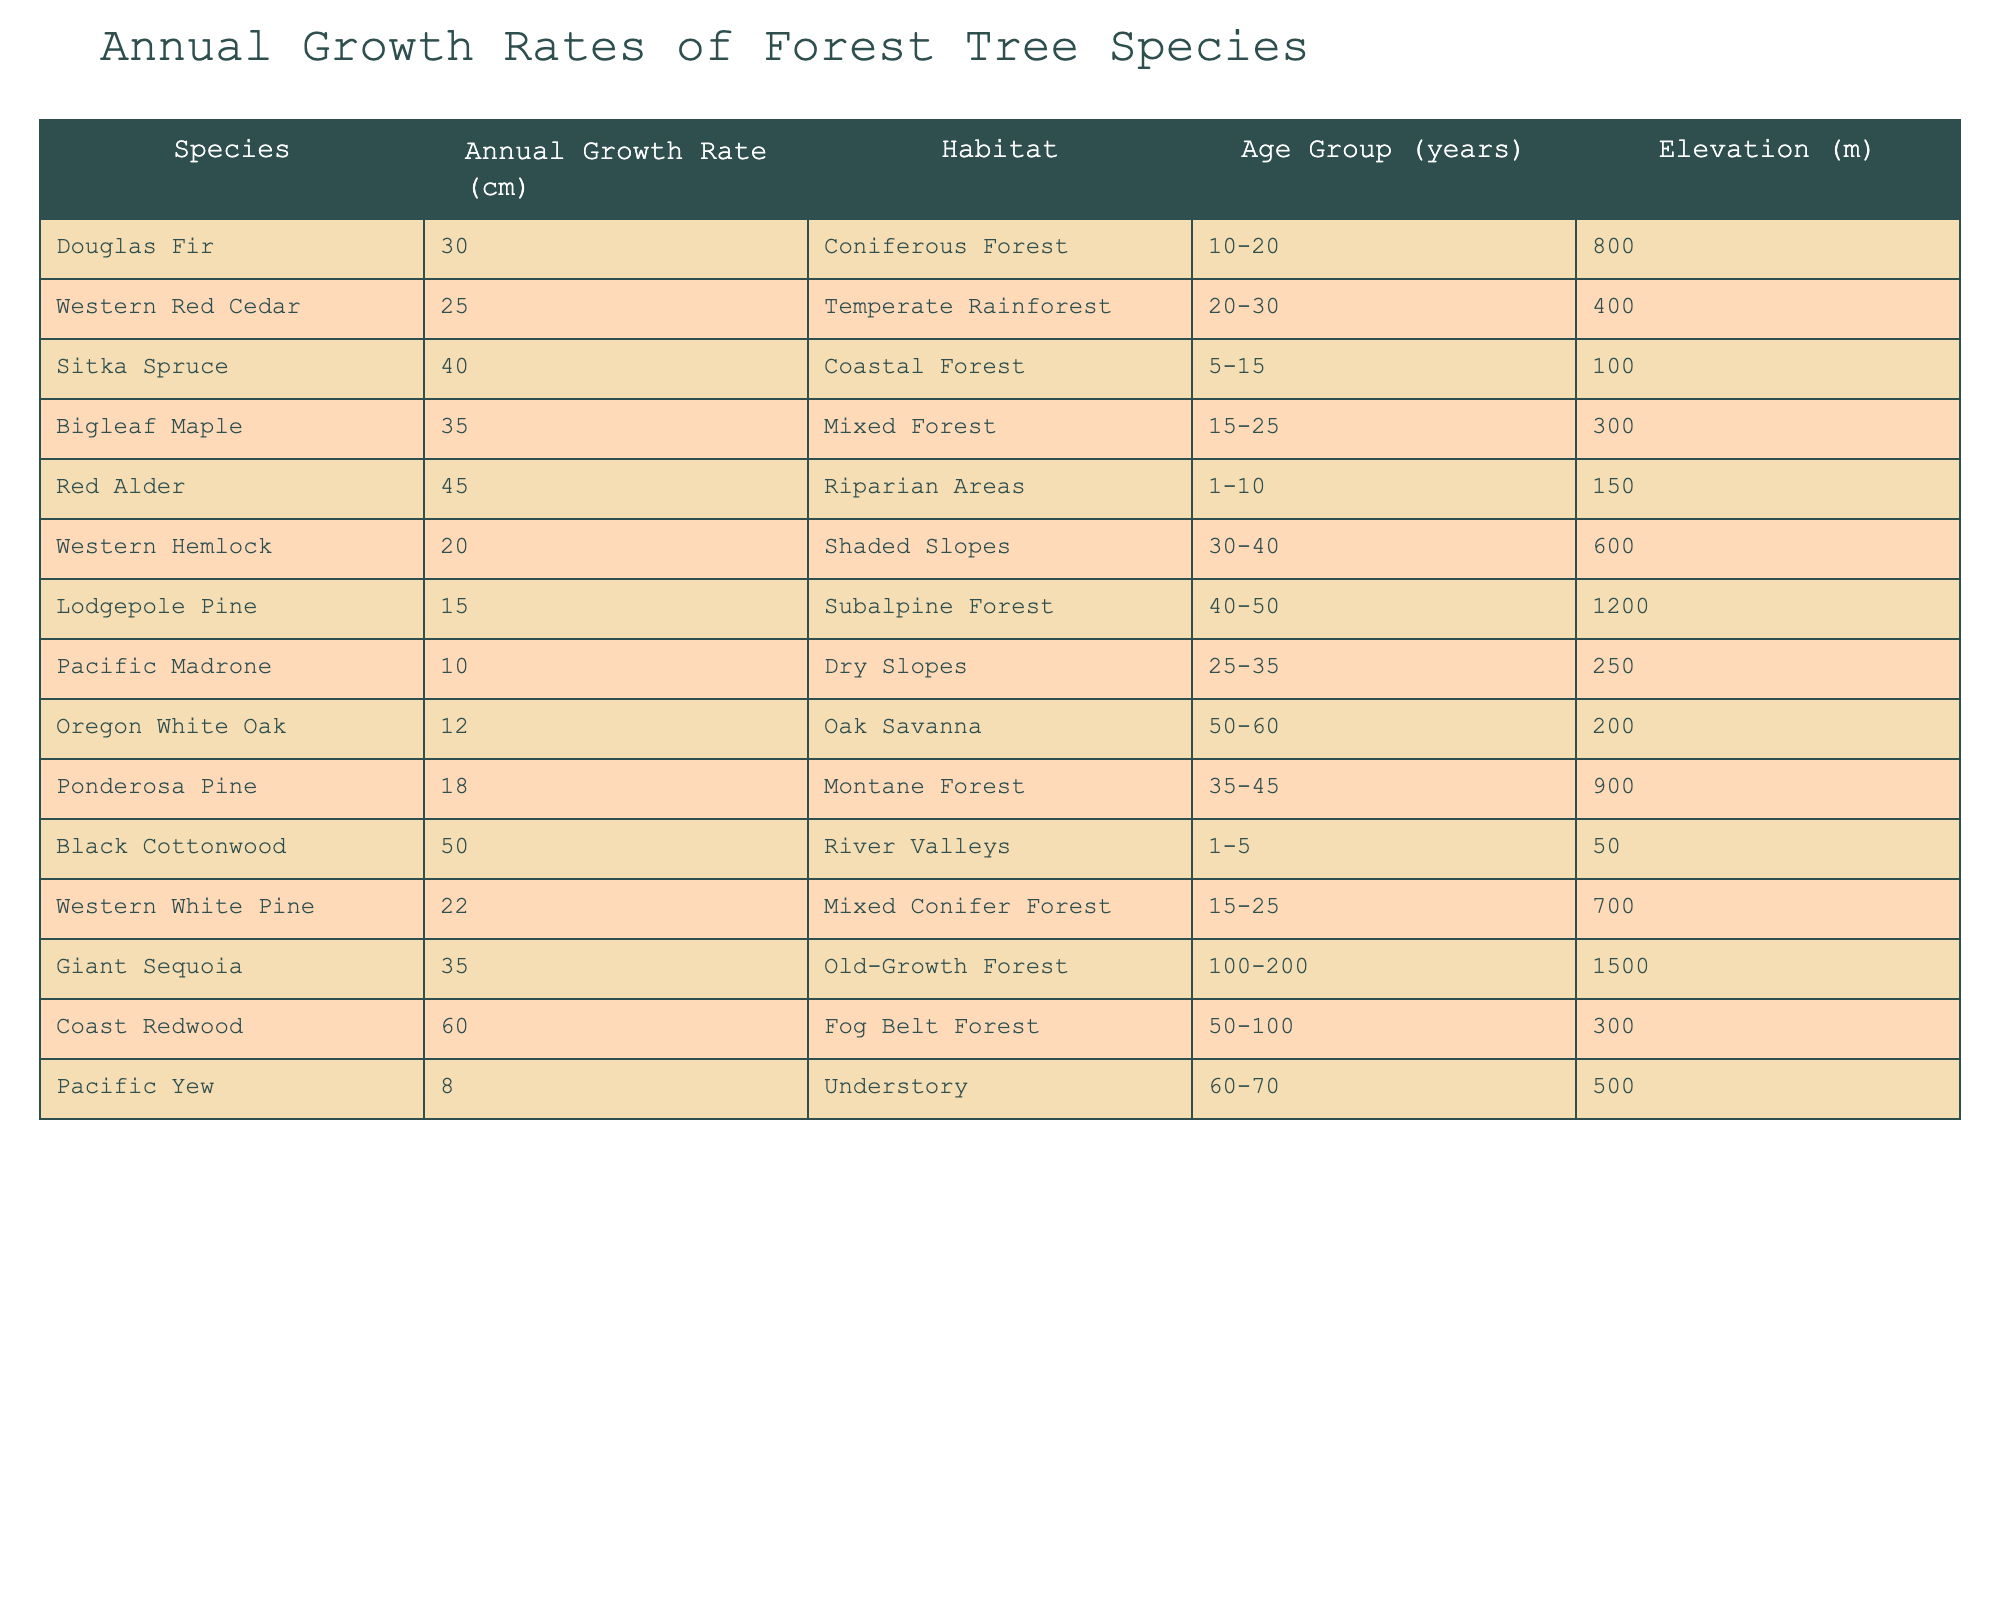What is the annual growth rate of the Coast Redwood? From the table, look for the row corresponding to the Coast Redwood species; the annual growth rate listed there is 60 cm.
Answer: 60 cm Which tree species has the highest annual growth rate? Scanning through the table, I can see that the Black Cottonwood has the highest growth rate at 50 cm, which is more than any other species.
Answer: Black Cottonwood What is the average growth rate of tree species found in Riparian Areas? The only species listed in Riparian Areas is the Red Alder, which has a growth rate of 45 cm. Since there is only one species, the average also equals 45 cm.
Answer: 45 cm Is the Western Hemlock's annual growth rate higher than that of the Lodgepole Pine? The Western Hemlock has an annual growth rate of 20 cm, and the Lodgepole Pine has a growth rate of 15 cm. Since 20 cm is greater than 15 cm, the statement is true.
Answer: Yes How many tree species have an annual growth rate of 30 cm or more? By reviewing the growth rates listed, I see that the following species meet the criterion: Douglas Fir, Sitka Spruce, Bigleaf Maple, Red Alder, Black Cottonwood, and Coast Redwood. That makes a total of 6 species.
Answer: 6 species What is the total annual growth rate of tree species in the Mixed Forest habitat? The table lists two species in Mixed Forest: Bigleaf Maple (35 cm) and Western White Pine (22 cm). Adding these values gives a total of 35 + 22 = 57 cm.
Answer: 57 cm Does the Pacific Yew have a higher growth rate than any species in the Temperate Rainforest? The Pacific Yew has a growth rate of 8 cm. In the Temperate Rainforest, the only species is Western Red Cedar with a growth rate of 25 cm. Since 8 cm is less than 25 cm, the statement is false.
Answer: No What is the difference in growth rates between the maximum and minimum of the species found in the coastal habitats? In the Coastal Forest, the Sitka Spruce has a rate of 40 cm; in the Fog Belt Forest, the Coast Redwood has a rate of 60 cm. To find the difference, calculate 60 - 40 = 20 cm.
Answer: 20 cm Which habitat has the tree species with the second highest annual growth rate? The tree with the highest growth rate is the Coast Redwood in the Fog Belt Forest (60 cm). The second highest is the Black Cottonwood in River Valleys (50 cm). Thus, River Valleys has the second highest species growth rate.
Answer: River Valleys What is the total growth rate of species found in the Understory and Dry Slopes habitats combined? The Pacific Yew (Understory) has a growth rate of 8 cm, while the Pacific Madrone (Dry Slopes) has a growth rate of 10 cm. Adding these gives 8 + 10 = 18 cm.
Answer: 18 cm 